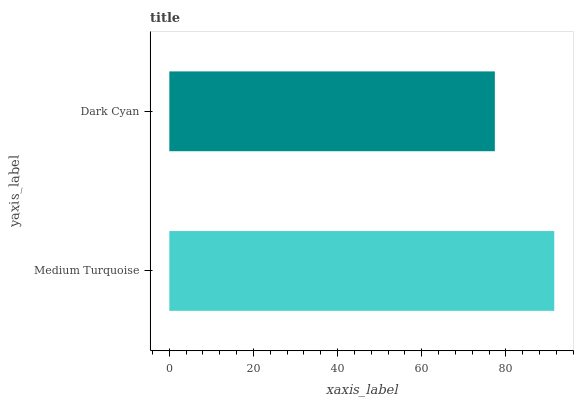Is Dark Cyan the minimum?
Answer yes or no. Yes. Is Medium Turquoise the maximum?
Answer yes or no. Yes. Is Dark Cyan the maximum?
Answer yes or no. No. Is Medium Turquoise greater than Dark Cyan?
Answer yes or no. Yes. Is Dark Cyan less than Medium Turquoise?
Answer yes or no. Yes. Is Dark Cyan greater than Medium Turquoise?
Answer yes or no. No. Is Medium Turquoise less than Dark Cyan?
Answer yes or no. No. Is Medium Turquoise the high median?
Answer yes or no. Yes. Is Dark Cyan the low median?
Answer yes or no. Yes. Is Dark Cyan the high median?
Answer yes or no. No. Is Medium Turquoise the low median?
Answer yes or no. No. 